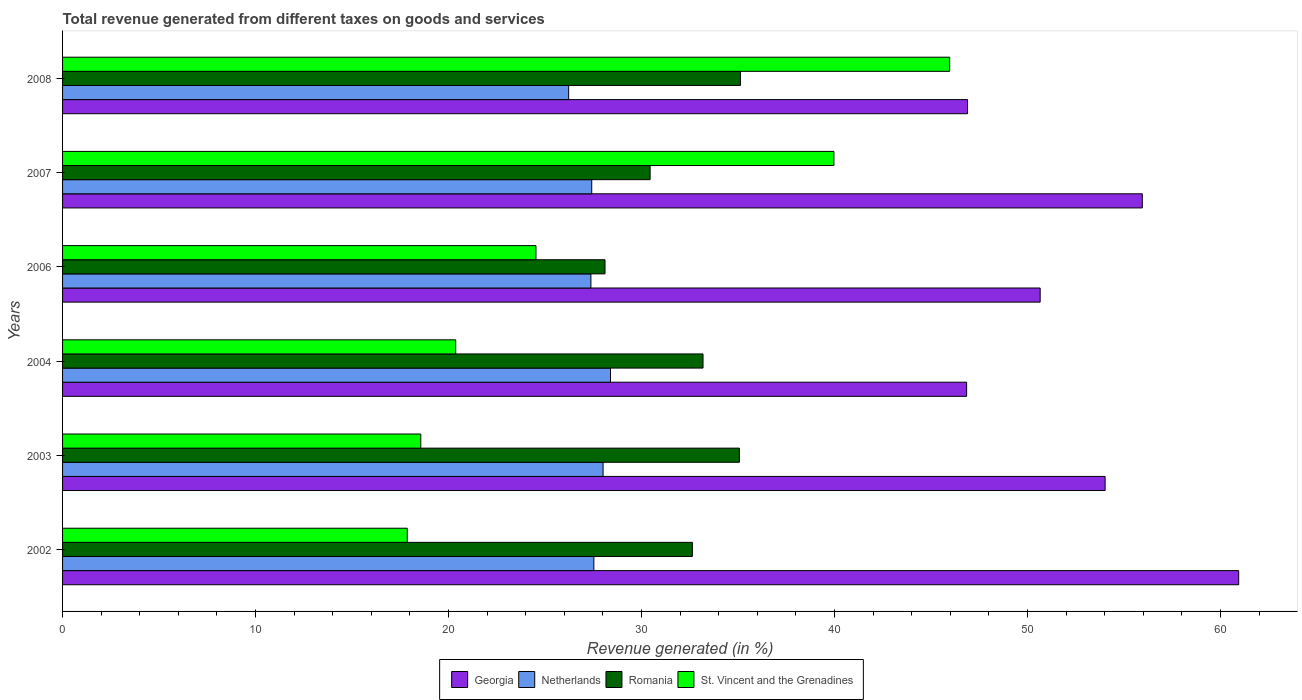In how many cases, is the number of bars for a given year not equal to the number of legend labels?
Offer a terse response. 0. What is the total revenue generated in Romania in 2003?
Your answer should be very brief. 35.07. Across all years, what is the maximum total revenue generated in St. Vincent and the Grenadines?
Your answer should be compact. 45.97. Across all years, what is the minimum total revenue generated in St. Vincent and the Grenadines?
Keep it short and to the point. 17.86. In which year was the total revenue generated in St. Vincent and the Grenadines maximum?
Ensure brevity in your answer.  2008. What is the total total revenue generated in Netherlands in the graph?
Offer a very short reply. 164.95. What is the difference between the total revenue generated in St. Vincent and the Grenadines in 2002 and that in 2008?
Ensure brevity in your answer.  -28.11. What is the difference between the total revenue generated in Netherlands in 2004 and the total revenue generated in St. Vincent and the Grenadines in 2006?
Your answer should be compact. 3.86. What is the average total revenue generated in St. Vincent and the Grenadines per year?
Your answer should be compact. 27.88. In the year 2007, what is the difference between the total revenue generated in Georgia and total revenue generated in St. Vincent and the Grenadines?
Your response must be concise. 15.98. What is the ratio of the total revenue generated in Georgia in 2002 to that in 2008?
Offer a very short reply. 1.3. What is the difference between the highest and the second highest total revenue generated in Netherlands?
Provide a short and direct response. 0.39. What is the difference between the highest and the lowest total revenue generated in Romania?
Your response must be concise. 7.02. In how many years, is the total revenue generated in St. Vincent and the Grenadines greater than the average total revenue generated in St. Vincent and the Grenadines taken over all years?
Provide a short and direct response. 2. Is it the case that in every year, the sum of the total revenue generated in Georgia and total revenue generated in Romania is greater than the sum of total revenue generated in St. Vincent and the Grenadines and total revenue generated in Netherlands?
Offer a very short reply. Yes. What does the 1st bar from the top in 2007 represents?
Offer a very short reply. St. Vincent and the Grenadines. What does the 2nd bar from the bottom in 2004 represents?
Your response must be concise. Netherlands. Is it the case that in every year, the sum of the total revenue generated in Georgia and total revenue generated in Romania is greater than the total revenue generated in Netherlands?
Provide a succinct answer. Yes. Are all the bars in the graph horizontal?
Your answer should be compact. Yes. How many years are there in the graph?
Your response must be concise. 6. What is the difference between two consecutive major ticks on the X-axis?
Provide a succinct answer. 10. Are the values on the major ticks of X-axis written in scientific E-notation?
Offer a terse response. No. Does the graph contain any zero values?
Offer a terse response. No. Does the graph contain grids?
Give a very brief answer. No. Where does the legend appear in the graph?
Ensure brevity in your answer.  Bottom center. How many legend labels are there?
Offer a very short reply. 4. How are the legend labels stacked?
Ensure brevity in your answer.  Horizontal. What is the title of the graph?
Your response must be concise. Total revenue generated from different taxes on goods and services. What is the label or title of the X-axis?
Make the answer very short. Revenue generated (in %). What is the label or title of the Y-axis?
Your answer should be compact. Years. What is the Revenue generated (in %) of Georgia in 2002?
Give a very brief answer. 60.94. What is the Revenue generated (in %) in Netherlands in 2002?
Provide a short and direct response. 27.53. What is the Revenue generated (in %) of Romania in 2002?
Offer a very short reply. 32.63. What is the Revenue generated (in %) of St. Vincent and the Grenadines in 2002?
Keep it short and to the point. 17.86. What is the Revenue generated (in %) of Georgia in 2003?
Your response must be concise. 54.02. What is the Revenue generated (in %) in Netherlands in 2003?
Give a very brief answer. 28.01. What is the Revenue generated (in %) of Romania in 2003?
Your response must be concise. 35.07. What is the Revenue generated (in %) in St. Vincent and the Grenadines in 2003?
Your answer should be compact. 18.56. What is the Revenue generated (in %) in Georgia in 2004?
Offer a terse response. 46.85. What is the Revenue generated (in %) of Netherlands in 2004?
Your response must be concise. 28.39. What is the Revenue generated (in %) of Romania in 2004?
Offer a terse response. 33.19. What is the Revenue generated (in %) of St. Vincent and the Grenadines in 2004?
Ensure brevity in your answer.  20.37. What is the Revenue generated (in %) in Georgia in 2006?
Provide a short and direct response. 50.66. What is the Revenue generated (in %) of Netherlands in 2006?
Provide a succinct answer. 27.38. What is the Revenue generated (in %) in Romania in 2006?
Keep it short and to the point. 28.11. What is the Revenue generated (in %) in St. Vincent and the Grenadines in 2006?
Give a very brief answer. 24.53. What is the Revenue generated (in %) of Georgia in 2007?
Keep it short and to the point. 55.95. What is the Revenue generated (in %) in Netherlands in 2007?
Provide a short and direct response. 27.42. What is the Revenue generated (in %) in Romania in 2007?
Provide a succinct answer. 30.45. What is the Revenue generated (in %) in St. Vincent and the Grenadines in 2007?
Your answer should be very brief. 39.97. What is the Revenue generated (in %) of Georgia in 2008?
Your answer should be very brief. 46.89. What is the Revenue generated (in %) in Netherlands in 2008?
Keep it short and to the point. 26.22. What is the Revenue generated (in %) in Romania in 2008?
Provide a short and direct response. 35.13. What is the Revenue generated (in %) in St. Vincent and the Grenadines in 2008?
Your response must be concise. 45.97. Across all years, what is the maximum Revenue generated (in %) of Georgia?
Your response must be concise. 60.94. Across all years, what is the maximum Revenue generated (in %) of Netherlands?
Give a very brief answer. 28.39. Across all years, what is the maximum Revenue generated (in %) in Romania?
Provide a short and direct response. 35.13. Across all years, what is the maximum Revenue generated (in %) of St. Vincent and the Grenadines?
Your answer should be compact. 45.97. Across all years, what is the minimum Revenue generated (in %) in Georgia?
Your answer should be very brief. 46.85. Across all years, what is the minimum Revenue generated (in %) in Netherlands?
Your response must be concise. 26.22. Across all years, what is the minimum Revenue generated (in %) in Romania?
Provide a succinct answer. 28.11. Across all years, what is the minimum Revenue generated (in %) in St. Vincent and the Grenadines?
Keep it short and to the point. 17.86. What is the total Revenue generated (in %) of Georgia in the graph?
Ensure brevity in your answer.  315.32. What is the total Revenue generated (in %) in Netherlands in the graph?
Your answer should be compact. 164.95. What is the total Revenue generated (in %) of Romania in the graph?
Make the answer very short. 194.57. What is the total Revenue generated (in %) in St. Vincent and the Grenadines in the graph?
Your response must be concise. 167.27. What is the difference between the Revenue generated (in %) of Georgia in 2002 and that in 2003?
Give a very brief answer. 6.92. What is the difference between the Revenue generated (in %) in Netherlands in 2002 and that in 2003?
Your answer should be very brief. -0.48. What is the difference between the Revenue generated (in %) of Romania in 2002 and that in 2003?
Provide a succinct answer. -2.44. What is the difference between the Revenue generated (in %) of St. Vincent and the Grenadines in 2002 and that in 2003?
Your response must be concise. -0.7. What is the difference between the Revenue generated (in %) of Georgia in 2002 and that in 2004?
Provide a succinct answer. 14.1. What is the difference between the Revenue generated (in %) in Netherlands in 2002 and that in 2004?
Your answer should be very brief. -0.86. What is the difference between the Revenue generated (in %) in Romania in 2002 and that in 2004?
Your answer should be compact. -0.55. What is the difference between the Revenue generated (in %) in St. Vincent and the Grenadines in 2002 and that in 2004?
Your answer should be compact. -2.51. What is the difference between the Revenue generated (in %) in Georgia in 2002 and that in 2006?
Your response must be concise. 10.29. What is the difference between the Revenue generated (in %) of Netherlands in 2002 and that in 2006?
Give a very brief answer. 0.15. What is the difference between the Revenue generated (in %) of Romania in 2002 and that in 2006?
Keep it short and to the point. 4.53. What is the difference between the Revenue generated (in %) in St. Vincent and the Grenadines in 2002 and that in 2006?
Offer a terse response. -6.67. What is the difference between the Revenue generated (in %) of Georgia in 2002 and that in 2007?
Your response must be concise. 4.99. What is the difference between the Revenue generated (in %) of Netherlands in 2002 and that in 2007?
Your response must be concise. 0.11. What is the difference between the Revenue generated (in %) of Romania in 2002 and that in 2007?
Provide a succinct answer. 2.19. What is the difference between the Revenue generated (in %) in St. Vincent and the Grenadines in 2002 and that in 2007?
Your answer should be very brief. -22.11. What is the difference between the Revenue generated (in %) of Georgia in 2002 and that in 2008?
Your answer should be very brief. 14.05. What is the difference between the Revenue generated (in %) in Netherlands in 2002 and that in 2008?
Provide a short and direct response. 1.31. What is the difference between the Revenue generated (in %) of Romania in 2002 and that in 2008?
Keep it short and to the point. -2.49. What is the difference between the Revenue generated (in %) of St. Vincent and the Grenadines in 2002 and that in 2008?
Offer a terse response. -28.11. What is the difference between the Revenue generated (in %) in Georgia in 2003 and that in 2004?
Your answer should be very brief. 7.18. What is the difference between the Revenue generated (in %) in Netherlands in 2003 and that in 2004?
Provide a short and direct response. -0.39. What is the difference between the Revenue generated (in %) of Romania in 2003 and that in 2004?
Give a very brief answer. 1.88. What is the difference between the Revenue generated (in %) in St. Vincent and the Grenadines in 2003 and that in 2004?
Offer a very short reply. -1.81. What is the difference between the Revenue generated (in %) of Georgia in 2003 and that in 2006?
Ensure brevity in your answer.  3.37. What is the difference between the Revenue generated (in %) in Netherlands in 2003 and that in 2006?
Your answer should be very brief. 0.63. What is the difference between the Revenue generated (in %) of Romania in 2003 and that in 2006?
Your answer should be very brief. 6.96. What is the difference between the Revenue generated (in %) in St. Vincent and the Grenadines in 2003 and that in 2006?
Offer a very short reply. -5.97. What is the difference between the Revenue generated (in %) in Georgia in 2003 and that in 2007?
Provide a short and direct response. -1.93. What is the difference between the Revenue generated (in %) in Netherlands in 2003 and that in 2007?
Provide a succinct answer. 0.59. What is the difference between the Revenue generated (in %) of Romania in 2003 and that in 2007?
Give a very brief answer. 4.62. What is the difference between the Revenue generated (in %) of St. Vincent and the Grenadines in 2003 and that in 2007?
Provide a short and direct response. -21.41. What is the difference between the Revenue generated (in %) in Georgia in 2003 and that in 2008?
Ensure brevity in your answer.  7.13. What is the difference between the Revenue generated (in %) of Netherlands in 2003 and that in 2008?
Provide a short and direct response. 1.78. What is the difference between the Revenue generated (in %) in Romania in 2003 and that in 2008?
Your response must be concise. -0.06. What is the difference between the Revenue generated (in %) of St. Vincent and the Grenadines in 2003 and that in 2008?
Offer a terse response. -27.41. What is the difference between the Revenue generated (in %) of Georgia in 2004 and that in 2006?
Your answer should be very brief. -3.81. What is the difference between the Revenue generated (in %) in Netherlands in 2004 and that in 2006?
Your answer should be compact. 1.02. What is the difference between the Revenue generated (in %) in Romania in 2004 and that in 2006?
Your response must be concise. 5.08. What is the difference between the Revenue generated (in %) of St. Vincent and the Grenadines in 2004 and that in 2006?
Your answer should be very brief. -4.16. What is the difference between the Revenue generated (in %) of Georgia in 2004 and that in 2007?
Offer a very short reply. -9.1. What is the difference between the Revenue generated (in %) in Netherlands in 2004 and that in 2007?
Provide a succinct answer. 0.97. What is the difference between the Revenue generated (in %) of Romania in 2004 and that in 2007?
Offer a terse response. 2.74. What is the difference between the Revenue generated (in %) in St. Vincent and the Grenadines in 2004 and that in 2007?
Make the answer very short. -19.6. What is the difference between the Revenue generated (in %) of Georgia in 2004 and that in 2008?
Ensure brevity in your answer.  -0.05. What is the difference between the Revenue generated (in %) in Netherlands in 2004 and that in 2008?
Your answer should be compact. 2.17. What is the difference between the Revenue generated (in %) in Romania in 2004 and that in 2008?
Ensure brevity in your answer.  -1.94. What is the difference between the Revenue generated (in %) of St. Vincent and the Grenadines in 2004 and that in 2008?
Your answer should be very brief. -25.6. What is the difference between the Revenue generated (in %) in Georgia in 2006 and that in 2007?
Offer a terse response. -5.29. What is the difference between the Revenue generated (in %) in Netherlands in 2006 and that in 2007?
Your response must be concise. -0.04. What is the difference between the Revenue generated (in %) of Romania in 2006 and that in 2007?
Offer a very short reply. -2.34. What is the difference between the Revenue generated (in %) of St. Vincent and the Grenadines in 2006 and that in 2007?
Your response must be concise. -15.44. What is the difference between the Revenue generated (in %) in Georgia in 2006 and that in 2008?
Make the answer very short. 3.76. What is the difference between the Revenue generated (in %) in Netherlands in 2006 and that in 2008?
Ensure brevity in your answer.  1.15. What is the difference between the Revenue generated (in %) in Romania in 2006 and that in 2008?
Your answer should be very brief. -7.02. What is the difference between the Revenue generated (in %) of St. Vincent and the Grenadines in 2006 and that in 2008?
Provide a short and direct response. -21.44. What is the difference between the Revenue generated (in %) in Georgia in 2007 and that in 2008?
Your response must be concise. 9.06. What is the difference between the Revenue generated (in %) of Netherlands in 2007 and that in 2008?
Keep it short and to the point. 1.2. What is the difference between the Revenue generated (in %) in Romania in 2007 and that in 2008?
Your answer should be very brief. -4.68. What is the difference between the Revenue generated (in %) of St. Vincent and the Grenadines in 2007 and that in 2008?
Ensure brevity in your answer.  -6. What is the difference between the Revenue generated (in %) of Georgia in 2002 and the Revenue generated (in %) of Netherlands in 2003?
Offer a very short reply. 32.94. What is the difference between the Revenue generated (in %) of Georgia in 2002 and the Revenue generated (in %) of Romania in 2003?
Give a very brief answer. 25.87. What is the difference between the Revenue generated (in %) in Georgia in 2002 and the Revenue generated (in %) in St. Vincent and the Grenadines in 2003?
Your answer should be compact. 42.38. What is the difference between the Revenue generated (in %) in Netherlands in 2002 and the Revenue generated (in %) in Romania in 2003?
Your response must be concise. -7.54. What is the difference between the Revenue generated (in %) in Netherlands in 2002 and the Revenue generated (in %) in St. Vincent and the Grenadines in 2003?
Make the answer very short. 8.97. What is the difference between the Revenue generated (in %) of Romania in 2002 and the Revenue generated (in %) of St. Vincent and the Grenadines in 2003?
Ensure brevity in your answer.  14.07. What is the difference between the Revenue generated (in %) in Georgia in 2002 and the Revenue generated (in %) in Netherlands in 2004?
Keep it short and to the point. 32.55. What is the difference between the Revenue generated (in %) in Georgia in 2002 and the Revenue generated (in %) in Romania in 2004?
Provide a short and direct response. 27.76. What is the difference between the Revenue generated (in %) in Georgia in 2002 and the Revenue generated (in %) in St. Vincent and the Grenadines in 2004?
Make the answer very short. 40.57. What is the difference between the Revenue generated (in %) in Netherlands in 2002 and the Revenue generated (in %) in Romania in 2004?
Ensure brevity in your answer.  -5.66. What is the difference between the Revenue generated (in %) in Netherlands in 2002 and the Revenue generated (in %) in St. Vincent and the Grenadines in 2004?
Give a very brief answer. 7.16. What is the difference between the Revenue generated (in %) in Romania in 2002 and the Revenue generated (in %) in St. Vincent and the Grenadines in 2004?
Provide a succinct answer. 12.26. What is the difference between the Revenue generated (in %) in Georgia in 2002 and the Revenue generated (in %) in Netherlands in 2006?
Ensure brevity in your answer.  33.57. What is the difference between the Revenue generated (in %) of Georgia in 2002 and the Revenue generated (in %) of Romania in 2006?
Provide a succinct answer. 32.84. What is the difference between the Revenue generated (in %) of Georgia in 2002 and the Revenue generated (in %) of St. Vincent and the Grenadines in 2006?
Make the answer very short. 36.41. What is the difference between the Revenue generated (in %) of Netherlands in 2002 and the Revenue generated (in %) of Romania in 2006?
Keep it short and to the point. -0.58. What is the difference between the Revenue generated (in %) of Netherlands in 2002 and the Revenue generated (in %) of St. Vincent and the Grenadines in 2006?
Offer a terse response. 3. What is the difference between the Revenue generated (in %) of Romania in 2002 and the Revenue generated (in %) of St. Vincent and the Grenadines in 2006?
Your answer should be very brief. 8.1. What is the difference between the Revenue generated (in %) of Georgia in 2002 and the Revenue generated (in %) of Netherlands in 2007?
Keep it short and to the point. 33.52. What is the difference between the Revenue generated (in %) in Georgia in 2002 and the Revenue generated (in %) in Romania in 2007?
Your answer should be compact. 30.5. What is the difference between the Revenue generated (in %) of Georgia in 2002 and the Revenue generated (in %) of St. Vincent and the Grenadines in 2007?
Give a very brief answer. 20.97. What is the difference between the Revenue generated (in %) of Netherlands in 2002 and the Revenue generated (in %) of Romania in 2007?
Your response must be concise. -2.92. What is the difference between the Revenue generated (in %) of Netherlands in 2002 and the Revenue generated (in %) of St. Vincent and the Grenadines in 2007?
Your response must be concise. -12.44. What is the difference between the Revenue generated (in %) in Romania in 2002 and the Revenue generated (in %) in St. Vincent and the Grenadines in 2007?
Your answer should be very brief. -7.33. What is the difference between the Revenue generated (in %) in Georgia in 2002 and the Revenue generated (in %) in Netherlands in 2008?
Offer a very short reply. 34.72. What is the difference between the Revenue generated (in %) in Georgia in 2002 and the Revenue generated (in %) in Romania in 2008?
Keep it short and to the point. 25.82. What is the difference between the Revenue generated (in %) of Georgia in 2002 and the Revenue generated (in %) of St. Vincent and the Grenadines in 2008?
Provide a short and direct response. 14.97. What is the difference between the Revenue generated (in %) of Netherlands in 2002 and the Revenue generated (in %) of Romania in 2008?
Ensure brevity in your answer.  -7.6. What is the difference between the Revenue generated (in %) in Netherlands in 2002 and the Revenue generated (in %) in St. Vincent and the Grenadines in 2008?
Provide a succinct answer. -18.44. What is the difference between the Revenue generated (in %) of Romania in 2002 and the Revenue generated (in %) of St. Vincent and the Grenadines in 2008?
Your answer should be very brief. -13.33. What is the difference between the Revenue generated (in %) in Georgia in 2003 and the Revenue generated (in %) in Netherlands in 2004?
Offer a very short reply. 25.63. What is the difference between the Revenue generated (in %) in Georgia in 2003 and the Revenue generated (in %) in Romania in 2004?
Make the answer very short. 20.84. What is the difference between the Revenue generated (in %) of Georgia in 2003 and the Revenue generated (in %) of St. Vincent and the Grenadines in 2004?
Ensure brevity in your answer.  33.65. What is the difference between the Revenue generated (in %) in Netherlands in 2003 and the Revenue generated (in %) in Romania in 2004?
Your answer should be compact. -5.18. What is the difference between the Revenue generated (in %) in Netherlands in 2003 and the Revenue generated (in %) in St. Vincent and the Grenadines in 2004?
Keep it short and to the point. 7.64. What is the difference between the Revenue generated (in %) in Romania in 2003 and the Revenue generated (in %) in St. Vincent and the Grenadines in 2004?
Offer a terse response. 14.7. What is the difference between the Revenue generated (in %) of Georgia in 2003 and the Revenue generated (in %) of Netherlands in 2006?
Provide a succinct answer. 26.65. What is the difference between the Revenue generated (in %) of Georgia in 2003 and the Revenue generated (in %) of Romania in 2006?
Your response must be concise. 25.91. What is the difference between the Revenue generated (in %) of Georgia in 2003 and the Revenue generated (in %) of St. Vincent and the Grenadines in 2006?
Make the answer very short. 29.49. What is the difference between the Revenue generated (in %) of Netherlands in 2003 and the Revenue generated (in %) of Romania in 2006?
Your response must be concise. -0.1. What is the difference between the Revenue generated (in %) of Netherlands in 2003 and the Revenue generated (in %) of St. Vincent and the Grenadines in 2006?
Offer a terse response. 3.48. What is the difference between the Revenue generated (in %) of Romania in 2003 and the Revenue generated (in %) of St. Vincent and the Grenadines in 2006?
Your response must be concise. 10.54. What is the difference between the Revenue generated (in %) of Georgia in 2003 and the Revenue generated (in %) of Netherlands in 2007?
Provide a succinct answer. 26.6. What is the difference between the Revenue generated (in %) in Georgia in 2003 and the Revenue generated (in %) in Romania in 2007?
Ensure brevity in your answer.  23.58. What is the difference between the Revenue generated (in %) of Georgia in 2003 and the Revenue generated (in %) of St. Vincent and the Grenadines in 2007?
Your answer should be compact. 14.05. What is the difference between the Revenue generated (in %) of Netherlands in 2003 and the Revenue generated (in %) of Romania in 2007?
Your answer should be compact. -2.44. What is the difference between the Revenue generated (in %) in Netherlands in 2003 and the Revenue generated (in %) in St. Vincent and the Grenadines in 2007?
Offer a terse response. -11.96. What is the difference between the Revenue generated (in %) in Romania in 2003 and the Revenue generated (in %) in St. Vincent and the Grenadines in 2007?
Your answer should be very brief. -4.9. What is the difference between the Revenue generated (in %) of Georgia in 2003 and the Revenue generated (in %) of Netherlands in 2008?
Make the answer very short. 27.8. What is the difference between the Revenue generated (in %) in Georgia in 2003 and the Revenue generated (in %) in Romania in 2008?
Your answer should be very brief. 18.9. What is the difference between the Revenue generated (in %) of Georgia in 2003 and the Revenue generated (in %) of St. Vincent and the Grenadines in 2008?
Make the answer very short. 8.05. What is the difference between the Revenue generated (in %) of Netherlands in 2003 and the Revenue generated (in %) of Romania in 2008?
Ensure brevity in your answer.  -7.12. What is the difference between the Revenue generated (in %) of Netherlands in 2003 and the Revenue generated (in %) of St. Vincent and the Grenadines in 2008?
Your answer should be very brief. -17.96. What is the difference between the Revenue generated (in %) of Romania in 2003 and the Revenue generated (in %) of St. Vincent and the Grenadines in 2008?
Provide a succinct answer. -10.9. What is the difference between the Revenue generated (in %) of Georgia in 2004 and the Revenue generated (in %) of Netherlands in 2006?
Ensure brevity in your answer.  19.47. What is the difference between the Revenue generated (in %) in Georgia in 2004 and the Revenue generated (in %) in Romania in 2006?
Make the answer very short. 18.74. What is the difference between the Revenue generated (in %) in Georgia in 2004 and the Revenue generated (in %) in St. Vincent and the Grenadines in 2006?
Your answer should be compact. 22.32. What is the difference between the Revenue generated (in %) of Netherlands in 2004 and the Revenue generated (in %) of Romania in 2006?
Keep it short and to the point. 0.28. What is the difference between the Revenue generated (in %) in Netherlands in 2004 and the Revenue generated (in %) in St. Vincent and the Grenadines in 2006?
Keep it short and to the point. 3.86. What is the difference between the Revenue generated (in %) of Romania in 2004 and the Revenue generated (in %) of St. Vincent and the Grenadines in 2006?
Offer a terse response. 8.66. What is the difference between the Revenue generated (in %) of Georgia in 2004 and the Revenue generated (in %) of Netherlands in 2007?
Provide a succinct answer. 19.43. What is the difference between the Revenue generated (in %) in Georgia in 2004 and the Revenue generated (in %) in St. Vincent and the Grenadines in 2007?
Give a very brief answer. 6.88. What is the difference between the Revenue generated (in %) of Netherlands in 2004 and the Revenue generated (in %) of Romania in 2007?
Your answer should be compact. -2.05. What is the difference between the Revenue generated (in %) in Netherlands in 2004 and the Revenue generated (in %) in St. Vincent and the Grenadines in 2007?
Ensure brevity in your answer.  -11.58. What is the difference between the Revenue generated (in %) in Romania in 2004 and the Revenue generated (in %) in St. Vincent and the Grenadines in 2007?
Your answer should be compact. -6.78. What is the difference between the Revenue generated (in %) in Georgia in 2004 and the Revenue generated (in %) in Netherlands in 2008?
Keep it short and to the point. 20.62. What is the difference between the Revenue generated (in %) of Georgia in 2004 and the Revenue generated (in %) of Romania in 2008?
Make the answer very short. 11.72. What is the difference between the Revenue generated (in %) of Georgia in 2004 and the Revenue generated (in %) of St. Vincent and the Grenadines in 2008?
Ensure brevity in your answer.  0.88. What is the difference between the Revenue generated (in %) in Netherlands in 2004 and the Revenue generated (in %) in Romania in 2008?
Your response must be concise. -6.73. What is the difference between the Revenue generated (in %) in Netherlands in 2004 and the Revenue generated (in %) in St. Vincent and the Grenadines in 2008?
Your answer should be very brief. -17.58. What is the difference between the Revenue generated (in %) of Romania in 2004 and the Revenue generated (in %) of St. Vincent and the Grenadines in 2008?
Your answer should be compact. -12.78. What is the difference between the Revenue generated (in %) of Georgia in 2006 and the Revenue generated (in %) of Netherlands in 2007?
Offer a very short reply. 23.24. What is the difference between the Revenue generated (in %) in Georgia in 2006 and the Revenue generated (in %) in Romania in 2007?
Provide a succinct answer. 20.21. What is the difference between the Revenue generated (in %) in Georgia in 2006 and the Revenue generated (in %) in St. Vincent and the Grenadines in 2007?
Provide a short and direct response. 10.69. What is the difference between the Revenue generated (in %) in Netherlands in 2006 and the Revenue generated (in %) in Romania in 2007?
Keep it short and to the point. -3.07. What is the difference between the Revenue generated (in %) of Netherlands in 2006 and the Revenue generated (in %) of St. Vincent and the Grenadines in 2007?
Offer a very short reply. -12.59. What is the difference between the Revenue generated (in %) of Romania in 2006 and the Revenue generated (in %) of St. Vincent and the Grenadines in 2007?
Provide a short and direct response. -11.86. What is the difference between the Revenue generated (in %) in Georgia in 2006 and the Revenue generated (in %) in Netherlands in 2008?
Offer a very short reply. 24.43. What is the difference between the Revenue generated (in %) of Georgia in 2006 and the Revenue generated (in %) of Romania in 2008?
Ensure brevity in your answer.  15.53. What is the difference between the Revenue generated (in %) of Georgia in 2006 and the Revenue generated (in %) of St. Vincent and the Grenadines in 2008?
Your response must be concise. 4.69. What is the difference between the Revenue generated (in %) in Netherlands in 2006 and the Revenue generated (in %) in Romania in 2008?
Make the answer very short. -7.75. What is the difference between the Revenue generated (in %) in Netherlands in 2006 and the Revenue generated (in %) in St. Vincent and the Grenadines in 2008?
Offer a very short reply. -18.59. What is the difference between the Revenue generated (in %) of Romania in 2006 and the Revenue generated (in %) of St. Vincent and the Grenadines in 2008?
Your answer should be compact. -17.86. What is the difference between the Revenue generated (in %) in Georgia in 2007 and the Revenue generated (in %) in Netherlands in 2008?
Keep it short and to the point. 29.73. What is the difference between the Revenue generated (in %) of Georgia in 2007 and the Revenue generated (in %) of Romania in 2008?
Offer a terse response. 20.82. What is the difference between the Revenue generated (in %) of Georgia in 2007 and the Revenue generated (in %) of St. Vincent and the Grenadines in 2008?
Provide a short and direct response. 9.98. What is the difference between the Revenue generated (in %) in Netherlands in 2007 and the Revenue generated (in %) in Romania in 2008?
Ensure brevity in your answer.  -7.71. What is the difference between the Revenue generated (in %) in Netherlands in 2007 and the Revenue generated (in %) in St. Vincent and the Grenadines in 2008?
Make the answer very short. -18.55. What is the difference between the Revenue generated (in %) of Romania in 2007 and the Revenue generated (in %) of St. Vincent and the Grenadines in 2008?
Ensure brevity in your answer.  -15.52. What is the average Revenue generated (in %) of Georgia per year?
Your answer should be very brief. 52.55. What is the average Revenue generated (in %) in Netherlands per year?
Make the answer very short. 27.49. What is the average Revenue generated (in %) of Romania per year?
Keep it short and to the point. 32.43. What is the average Revenue generated (in %) of St. Vincent and the Grenadines per year?
Your response must be concise. 27.88. In the year 2002, what is the difference between the Revenue generated (in %) of Georgia and Revenue generated (in %) of Netherlands?
Ensure brevity in your answer.  33.41. In the year 2002, what is the difference between the Revenue generated (in %) in Georgia and Revenue generated (in %) in Romania?
Give a very brief answer. 28.31. In the year 2002, what is the difference between the Revenue generated (in %) in Georgia and Revenue generated (in %) in St. Vincent and the Grenadines?
Your answer should be compact. 43.08. In the year 2002, what is the difference between the Revenue generated (in %) of Netherlands and Revenue generated (in %) of Romania?
Keep it short and to the point. -5.1. In the year 2002, what is the difference between the Revenue generated (in %) in Netherlands and Revenue generated (in %) in St. Vincent and the Grenadines?
Make the answer very short. 9.67. In the year 2002, what is the difference between the Revenue generated (in %) of Romania and Revenue generated (in %) of St. Vincent and the Grenadines?
Your answer should be compact. 14.77. In the year 2003, what is the difference between the Revenue generated (in %) in Georgia and Revenue generated (in %) in Netherlands?
Ensure brevity in your answer.  26.02. In the year 2003, what is the difference between the Revenue generated (in %) in Georgia and Revenue generated (in %) in Romania?
Your response must be concise. 18.95. In the year 2003, what is the difference between the Revenue generated (in %) of Georgia and Revenue generated (in %) of St. Vincent and the Grenadines?
Give a very brief answer. 35.46. In the year 2003, what is the difference between the Revenue generated (in %) in Netherlands and Revenue generated (in %) in Romania?
Provide a short and direct response. -7.06. In the year 2003, what is the difference between the Revenue generated (in %) in Netherlands and Revenue generated (in %) in St. Vincent and the Grenadines?
Your answer should be compact. 9.45. In the year 2003, what is the difference between the Revenue generated (in %) of Romania and Revenue generated (in %) of St. Vincent and the Grenadines?
Keep it short and to the point. 16.51. In the year 2004, what is the difference between the Revenue generated (in %) in Georgia and Revenue generated (in %) in Netherlands?
Ensure brevity in your answer.  18.45. In the year 2004, what is the difference between the Revenue generated (in %) of Georgia and Revenue generated (in %) of Romania?
Provide a short and direct response. 13.66. In the year 2004, what is the difference between the Revenue generated (in %) in Georgia and Revenue generated (in %) in St. Vincent and the Grenadines?
Your answer should be very brief. 26.47. In the year 2004, what is the difference between the Revenue generated (in %) in Netherlands and Revenue generated (in %) in Romania?
Offer a very short reply. -4.79. In the year 2004, what is the difference between the Revenue generated (in %) in Netherlands and Revenue generated (in %) in St. Vincent and the Grenadines?
Offer a terse response. 8.02. In the year 2004, what is the difference between the Revenue generated (in %) of Romania and Revenue generated (in %) of St. Vincent and the Grenadines?
Keep it short and to the point. 12.81. In the year 2006, what is the difference between the Revenue generated (in %) of Georgia and Revenue generated (in %) of Netherlands?
Keep it short and to the point. 23.28. In the year 2006, what is the difference between the Revenue generated (in %) of Georgia and Revenue generated (in %) of Romania?
Give a very brief answer. 22.55. In the year 2006, what is the difference between the Revenue generated (in %) in Georgia and Revenue generated (in %) in St. Vincent and the Grenadines?
Your response must be concise. 26.13. In the year 2006, what is the difference between the Revenue generated (in %) in Netherlands and Revenue generated (in %) in Romania?
Provide a short and direct response. -0.73. In the year 2006, what is the difference between the Revenue generated (in %) in Netherlands and Revenue generated (in %) in St. Vincent and the Grenadines?
Ensure brevity in your answer.  2.85. In the year 2006, what is the difference between the Revenue generated (in %) of Romania and Revenue generated (in %) of St. Vincent and the Grenadines?
Make the answer very short. 3.58. In the year 2007, what is the difference between the Revenue generated (in %) of Georgia and Revenue generated (in %) of Netherlands?
Give a very brief answer. 28.53. In the year 2007, what is the difference between the Revenue generated (in %) of Georgia and Revenue generated (in %) of Romania?
Provide a succinct answer. 25.5. In the year 2007, what is the difference between the Revenue generated (in %) of Georgia and Revenue generated (in %) of St. Vincent and the Grenadines?
Keep it short and to the point. 15.98. In the year 2007, what is the difference between the Revenue generated (in %) in Netherlands and Revenue generated (in %) in Romania?
Offer a terse response. -3.03. In the year 2007, what is the difference between the Revenue generated (in %) in Netherlands and Revenue generated (in %) in St. Vincent and the Grenadines?
Provide a succinct answer. -12.55. In the year 2007, what is the difference between the Revenue generated (in %) in Romania and Revenue generated (in %) in St. Vincent and the Grenadines?
Ensure brevity in your answer.  -9.52. In the year 2008, what is the difference between the Revenue generated (in %) in Georgia and Revenue generated (in %) in Netherlands?
Make the answer very short. 20.67. In the year 2008, what is the difference between the Revenue generated (in %) in Georgia and Revenue generated (in %) in Romania?
Offer a terse response. 11.77. In the year 2008, what is the difference between the Revenue generated (in %) of Georgia and Revenue generated (in %) of St. Vincent and the Grenadines?
Provide a succinct answer. 0.92. In the year 2008, what is the difference between the Revenue generated (in %) in Netherlands and Revenue generated (in %) in Romania?
Provide a succinct answer. -8.9. In the year 2008, what is the difference between the Revenue generated (in %) in Netherlands and Revenue generated (in %) in St. Vincent and the Grenadines?
Give a very brief answer. -19.75. In the year 2008, what is the difference between the Revenue generated (in %) in Romania and Revenue generated (in %) in St. Vincent and the Grenadines?
Offer a very short reply. -10.84. What is the ratio of the Revenue generated (in %) in Georgia in 2002 to that in 2003?
Offer a very short reply. 1.13. What is the ratio of the Revenue generated (in %) in Netherlands in 2002 to that in 2003?
Provide a succinct answer. 0.98. What is the ratio of the Revenue generated (in %) in Romania in 2002 to that in 2003?
Your response must be concise. 0.93. What is the ratio of the Revenue generated (in %) in St. Vincent and the Grenadines in 2002 to that in 2003?
Ensure brevity in your answer.  0.96. What is the ratio of the Revenue generated (in %) of Georgia in 2002 to that in 2004?
Offer a very short reply. 1.3. What is the ratio of the Revenue generated (in %) of Netherlands in 2002 to that in 2004?
Your response must be concise. 0.97. What is the ratio of the Revenue generated (in %) in Romania in 2002 to that in 2004?
Give a very brief answer. 0.98. What is the ratio of the Revenue generated (in %) of St. Vincent and the Grenadines in 2002 to that in 2004?
Your answer should be compact. 0.88. What is the ratio of the Revenue generated (in %) in Georgia in 2002 to that in 2006?
Provide a short and direct response. 1.2. What is the ratio of the Revenue generated (in %) of Netherlands in 2002 to that in 2006?
Ensure brevity in your answer.  1.01. What is the ratio of the Revenue generated (in %) in Romania in 2002 to that in 2006?
Ensure brevity in your answer.  1.16. What is the ratio of the Revenue generated (in %) of St. Vincent and the Grenadines in 2002 to that in 2006?
Make the answer very short. 0.73. What is the ratio of the Revenue generated (in %) in Georgia in 2002 to that in 2007?
Offer a very short reply. 1.09. What is the ratio of the Revenue generated (in %) of Romania in 2002 to that in 2007?
Your answer should be very brief. 1.07. What is the ratio of the Revenue generated (in %) in St. Vincent and the Grenadines in 2002 to that in 2007?
Ensure brevity in your answer.  0.45. What is the ratio of the Revenue generated (in %) in Georgia in 2002 to that in 2008?
Your response must be concise. 1.3. What is the ratio of the Revenue generated (in %) of Netherlands in 2002 to that in 2008?
Keep it short and to the point. 1.05. What is the ratio of the Revenue generated (in %) of Romania in 2002 to that in 2008?
Give a very brief answer. 0.93. What is the ratio of the Revenue generated (in %) of St. Vincent and the Grenadines in 2002 to that in 2008?
Make the answer very short. 0.39. What is the ratio of the Revenue generated (in %) in Georgia in 2003 to that in 2004?
Offer a very short reply. 1.15. What is the ratio of the Revenue generated (in %) in Netherlands in 2003 to that in 2004?
Your answer should be compact. 0.99. What is the ratio of the Revenue generated (in %) in Romania in 2003 to that in 2004?
Ensure brevity in your answer.  1.06. What is the ratio of the Revenue generated (in %) in St. Vincent and the Grenadines in 2003 to that in 2004?
Provide a succinct answer. 0.91. What is the ratio of the Revenue generated (in %) in Georgia in 2003 to that in 2006?
Provide a short and direct response. 1.07. What is the ratio of the Revenue generated (in %) in Romania in 2003 to that in 2006?
Offer a terse response. 1.25. What is the ratio of the Revenue generated (in %) in St. Vincent and the Grenadines in 2003 to that in 2006?
Provide a short and direct response. 0.76. What is the ratio of the Revenue generated (in %) of Georgia in 2003 to that in 2007?
Your answer should be very brief. 0.97. What is the ratio of the Revenue generated (in %) of Netherlands in 2003 to that in 2007?
Keep it short and to the point. 1.02. What is the ratio of the Revenue generated (in %) of Romania in 2003 to that in 2007?
Offer a very short reply. 1.15. What is the ratio of the Revenue generated (in %) in St. Vincent and the Grenadines in 2003 to that in 2007?
Keep it short and to the point. 0.46. What is the ratio of the Revenue generated (in %) in Georgia in 2003 to that in 2008?
Your response must be concise. 1.15. What is the ratio of the Revenue generated (in %) of Netherlands in 2003 to that in 2008?
Provide a short and direct response. 1.07. What is the ratio of the Revenue generated (in %) in St. Vincent and the Grenadines in 2003 to that in 2008?
Your answer should be very brief. 0.4. What is the ratio of the Revenue generated (in %) of Georgia in 2004 to that in 2006?
Offer a very short reply. 0.92. What is the ratio of the Revenue generated (in %) in Netherlands in 2004 to that in 2006?
Give a very brief answer. 1.04. What is the ratio of the Revenue generated (in %) of Romania in 2004 to that in 2006?
Your answer should be compact. 1.18. What is the ratio of the Revenue generated (in %) in St. Vincent and the Grenadines in 2004 to that in 2006?
Provide a succinct answer. 0.83. What is the ratio of the Revenue generated (in %) in Georgia in 2004 to that in 2007?
Keep it short and to the point. 0.84. What is the ratio of the Revenue generated (in %) of Netherlands in 2004 to that in 2007?
Your answer should be compact. 1.04. What is the ratio of the Revenue generated (in %) in Romania in 2004 to that in 2007?
Offer a terse response. 1.09. What is the ratio of the Revenue generated (in %) of St. Vincent and the Grenadines in 2004 to that in 2007?
Ensure brevity in your answer.  0.51. What is the ratio of the Revenue generated (in %) in Georgia in 2004 to that in 2008?
Provide a short and direct response. 1. What is the ratio of the Revenue generated (in %) of Netherlands in 2004 to that in 2008?
Give a very brief answer. 1.08. What is the ratio of the Revenue generated (in %) in Romania in 2004 to that in 2008?
Offer a terse response. 0.94. What is the ratio of the Revenue generated (in %) in St. Vincent and the Grenadines in 2004 to that in 2008?
Offer a terse response. 0.44. What is the ratio of the Revenue generated (in %) of Georgia in 2006 to that in 2007?
Offer a very short reply. 0.91. What is the ratio of the Revenue generated (in %) of Romania in 2006 to that in 2007?
Your answer should be very brief. 0.92. What is the ratio of the Revenue generated (in %) in St. Vincent and the Grenadines in 2006 to that in 2007?
Your answer should be compact. 0.61. What is the ratio of the Revenue generated (in %) of Georgia in 2006 to that in 2008?
Offer a terse response. 1.08. What is the ratio of the Revenue generated (in %) in Netherlands in 2006 to that in 2008?
Offer a very short reply. 1.04. What is the ratio of the Revenue generated (in %) in Romania in 2006 to that in 2008?
Provide a short and direct response. 0.8. What is the ratio of the Revenue generated (in %) in St. Vincent and the Grenadines in 2006 to that in 2008?
Offer a very short reply. 0.53. What is the ratio of the Revenue generated (in %) of Georgia in 2007 to that in 2008?
Keep it short and to the point. 1.19. What is the ratio of the Revenue generated (in %) in Netherlands in 2007 to that in 2008?
Your response must be concise. 1.05. What is the ratio of the Revenue generated (in %) of Romania in 2007 to that in 2008?
Keep it short and to the point. 0.87. What is the ratio of the Revenue generated (in %) of St. Vincent and the Grenadines in 2007 to that in 2008?
Give a very brief answer. 0.87. What is the difference between the highest and the second highest Revenue generated (in %) in Georgia?
Your answer should be very brief. 4.99. What is the difference between the highest and the second highest Revenue generated (in %) in Netherlands?
Your answer should be compact. 0.39. What is the difference between the highest and the second highest Revenue generated (in %) of Romania?
Provide a short and direct response. 0.06. What is the difference between the highest and the second highest Revenue generated (in %) in St. Vincent and the Grenadines?
Offer a very short reply. 6. What is the difference between the highest and the lowest Revenue generated (in %) in Georgia?
Your answer should be very brief. 14.1. What is the difference between the highest and the lowest Revenue generated (in %) in Netherlands?
Your answer should be compact. 2.17. What is the difference between the highest and the lowest Revenue generated (in %) in Romania?
Offer a terse response. 7.02. What is the difference between the highest and the lowest Revenue generated (in %) in St. Vincent and the Grenadines?
Your answer should be very brief. 28.11. 